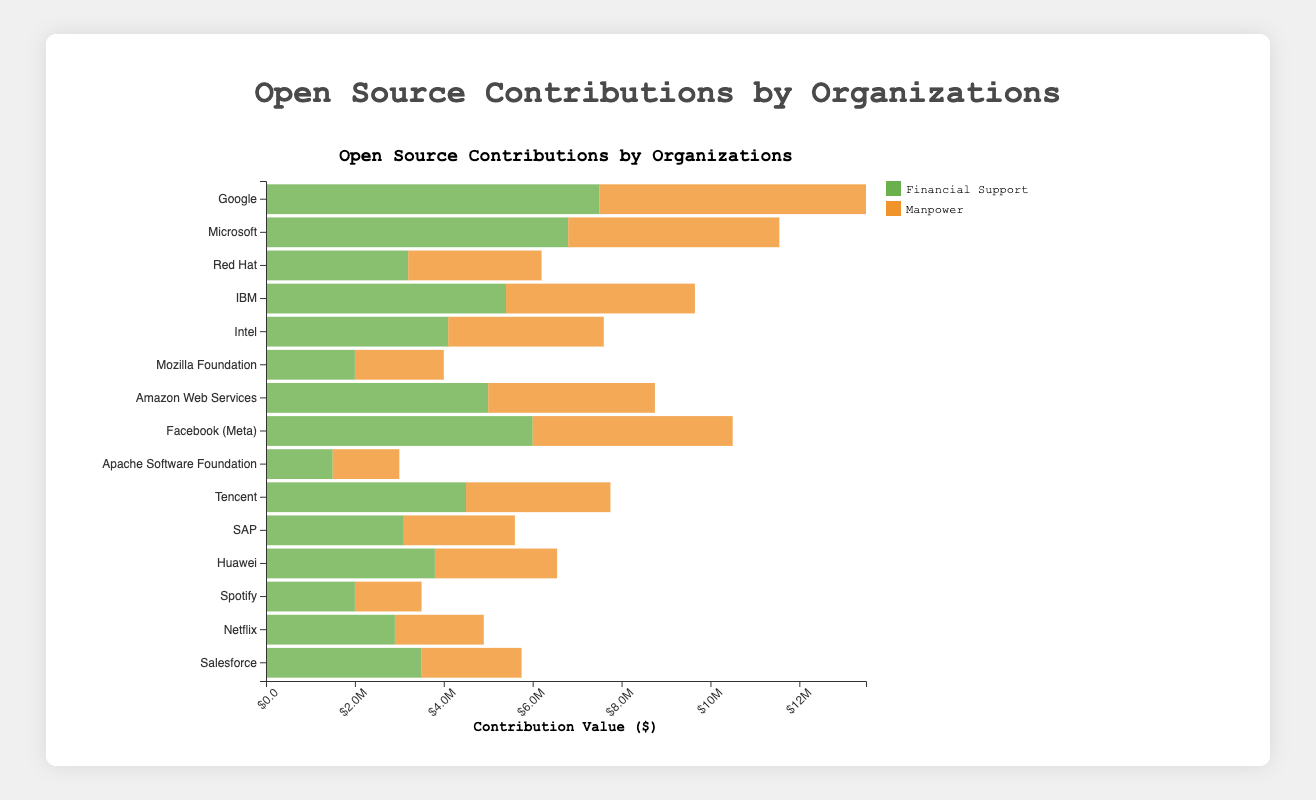Which organization contributes the highest financial support to open-source projects? By observing the lengths of the green bars in the chart, you can see that Google has the longest green bar, indicating it contributes the highest financial support.
Answer: Google Which organization has the most manpower contributing to open-source projects? By comparing the lengths of the orange bars in the chart, you can see that Google also has the longest orange bar, indicating it provides the most manpower.
Answer: Google Between Google and Microsoft, which organization has a higher total contribution value? Google contributes $7,500,000 in financial support and has 120 manpower, while Microsoft contributes $6,800,000 in financial support and has 95 manpower. Multiply the manpower by 50,000 to get labor value: Google (120 * 50,000 = $6,000,000), Microsoft (95 * 50,000 = $4,750,000). Sum the financial and labor values: Google ($7,500,000 + $6,000,000 = $13,500,000), Microsoft ($6,800,000 + $4,750,000 = $11,550,000).
Answer: Google How much more does Red Hat contribute in financial support compared to the Mozilla Foundation? Red Hat's financial support is $3,200,000, and Mozilla Foundation's financial support is $2,000,000. Subtract the smaller amount from the larger one: $3,200,000 - $2,000,000 = $1,200,000.
Answer: $1,200,000 Which organization contributes more financial support: Facebook (Meta) or Tencent? By observing the green bars, Facebook (Meta) has a financial support of $6,000,000 and Tencent $4,500,000. Facebook (Meta)'s financial support is higher.
Answer: Facebook (Meta) Which two organizations have exactly the same manpower contribution? By observing the orange bars, Spotify and Apache Software Foundation both have a manpower of 30.
Answer: Spotify and Apache Software Foundation What’s the total financial support contribution from all non-profit organizations in the chart? Mozilla Foundation contributes $2,000,000 and Apache Software Foundation contributes $1,500,000. Sum these values: $2,000,000 + $1,500,000 = $3,500,000.
Answer: $3,500,000 What is the combined manpower contribution for Google, Microsoft, and IBM? Google has 120, Microsoft has 95, and IBM has 85 manpower. Sum these values: 120 + 95 + 85 = 300.
Answer: 300 Does Amazon Web Services contribute more in financial support or manpower value, and by how much? Amazon Web Services contributes $5,000,000 in financial support and has 75 manpower. Calculate the manpower value: 75 * 50,000 = $3,750,000. The financial support is higher. Subtract the manpower value from the financial support: $5,000,000 - $3,750,000 = $1,250,000.
Answer: Financial support, by $1,250,000 